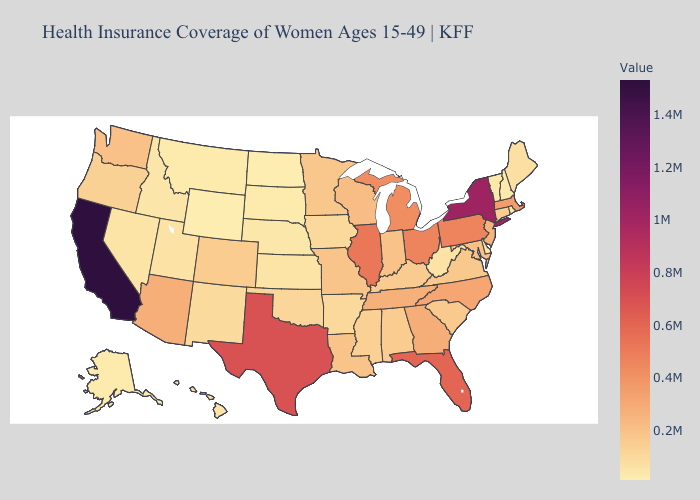Does New Hampshire have the lowest value in the Northeast?
Answer briefly. Yes. Which states hav the highest value in the MidWest?
Give a very brief answer. Illinois. Does Rhode Island have a lower value than Pennsylvania?
Concise answer only. Yes. Is the legend a continuous bar?
Be succinct. Yes. Does Pennsylvania have a lower value than Texas?
Be succinct. Yes. Among the states that border New York , which have the highest value?
Short answer required. Pennsylvania. 